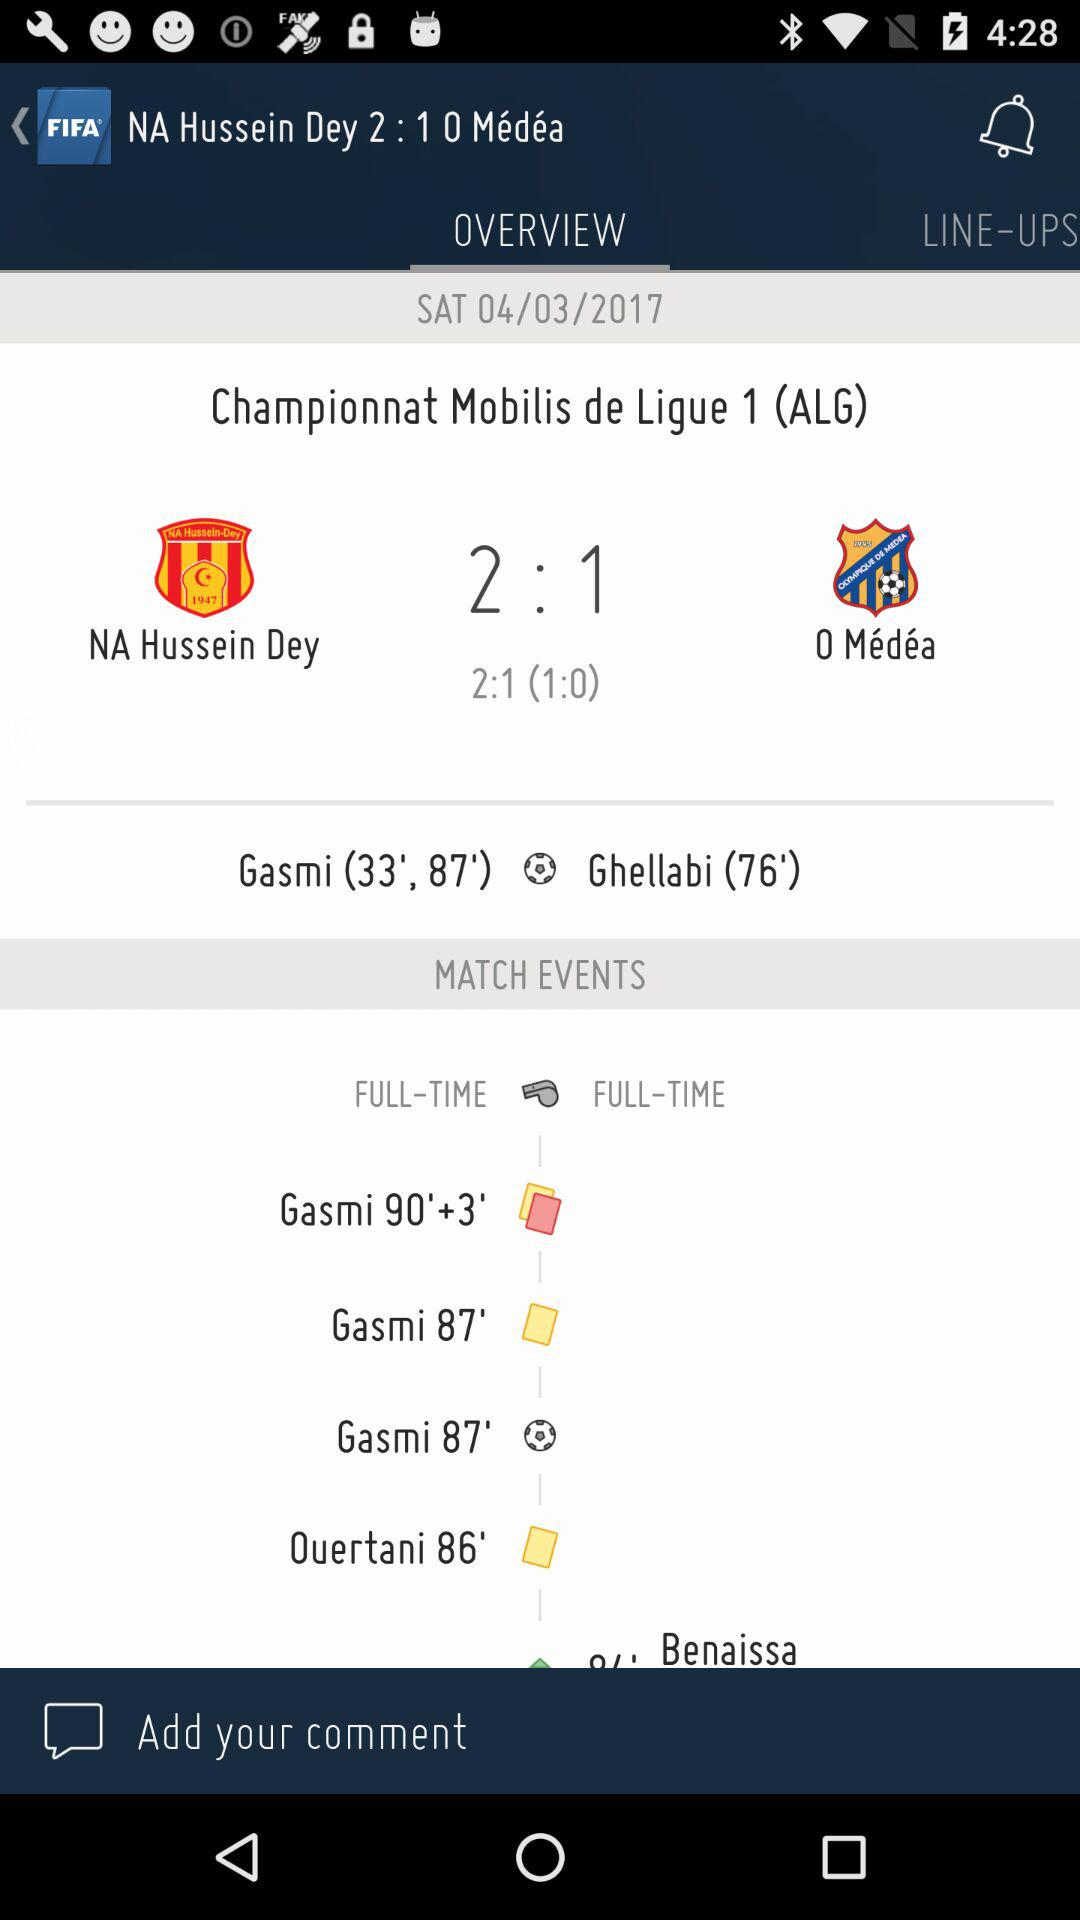How many more goals did NA Hussein Dey score than O Medee?
Answer the question using a single word or phrase. 1 